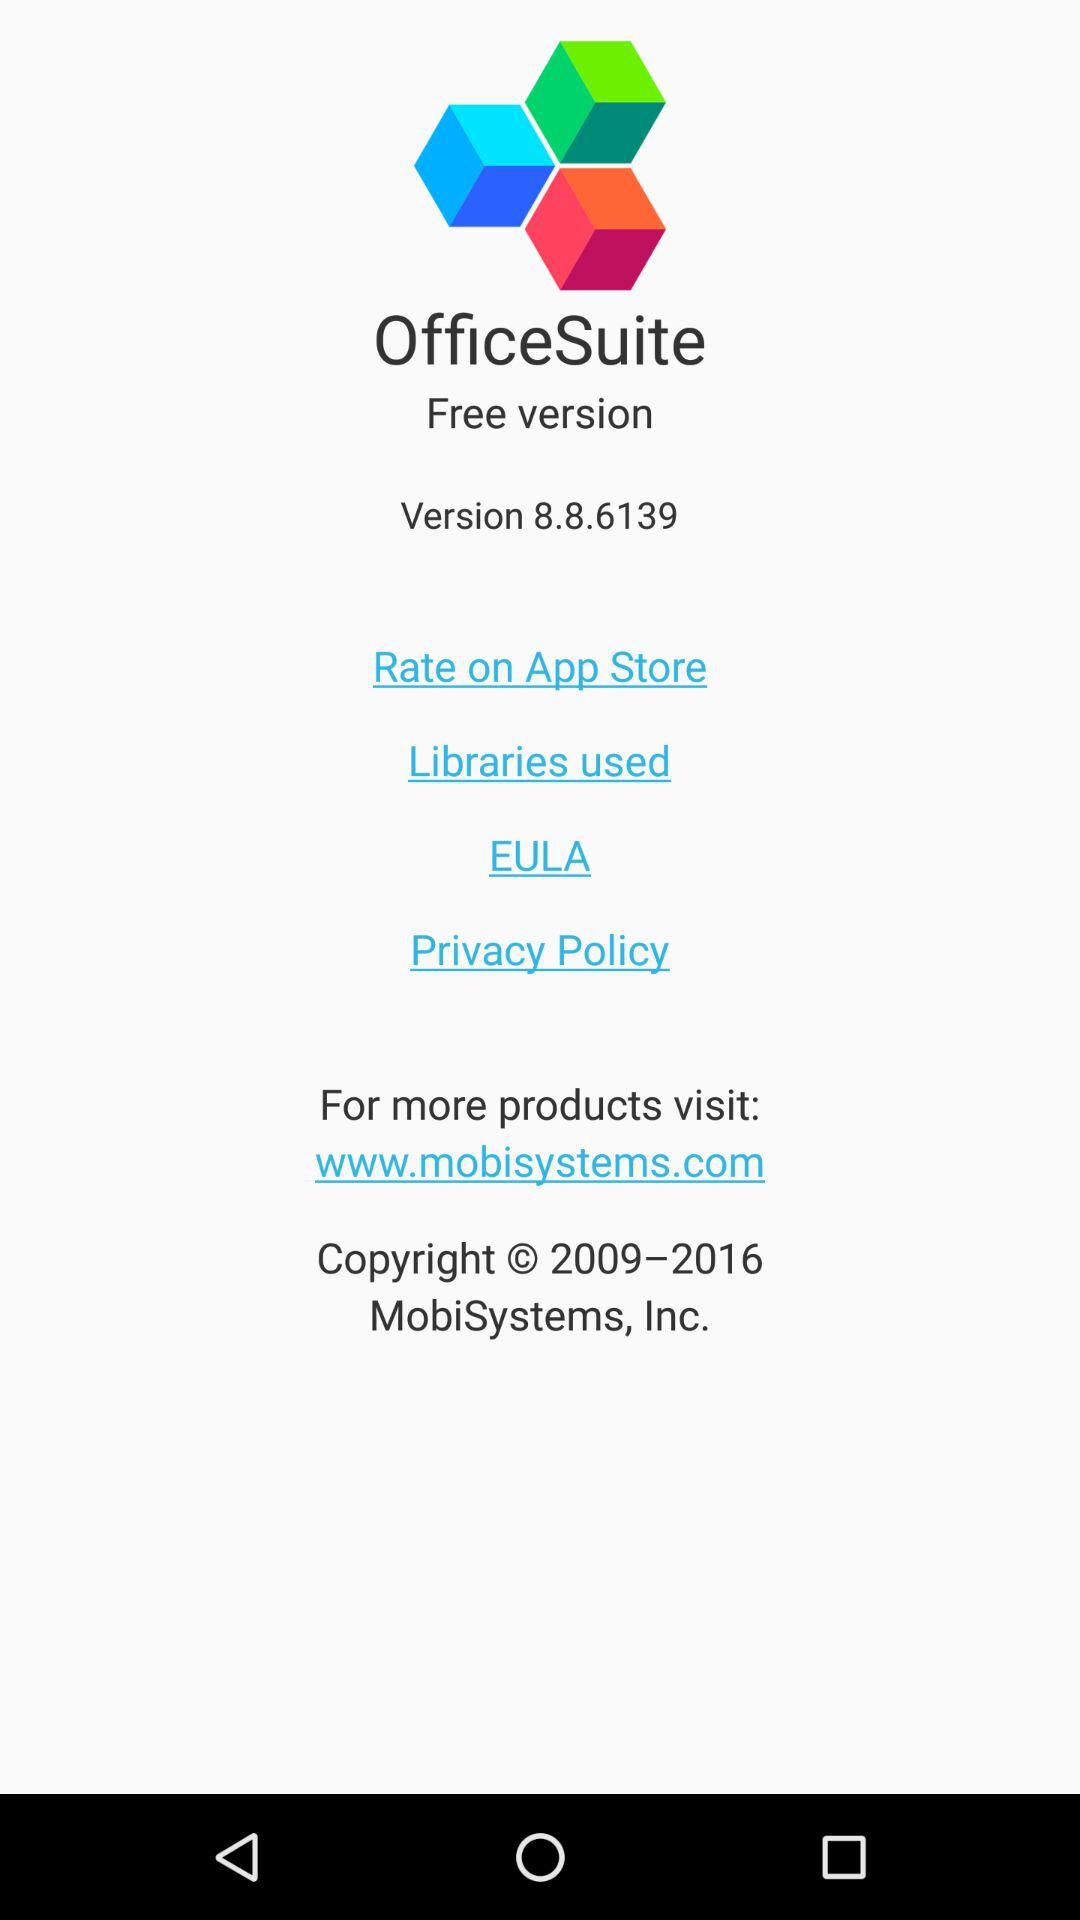What is the version for the OfficeSuite? The version is 8.8.6139. 